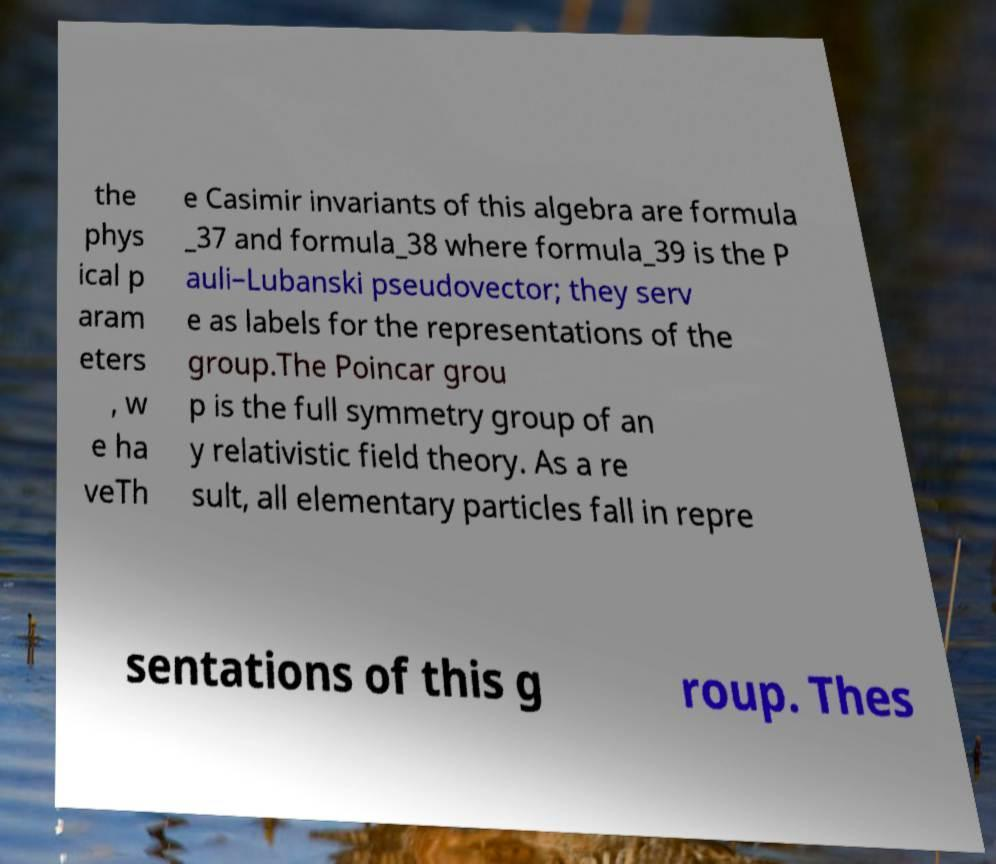For documentation purposes, I need the text within this image transcribed. Could you provide that? the phys ical p aram eters , w e ha veTh e Casimir invariants of this algebra are formula _37 and formula_38 where formula_39 is the P auli–Lubanski pseudovector; they serv e as labels for the representations of the group.The Poincar grou p is the full symmetry group of an y relativistic field theory. As a re sult, all elementary particles fall in repre sentations of this g roup. Thes 